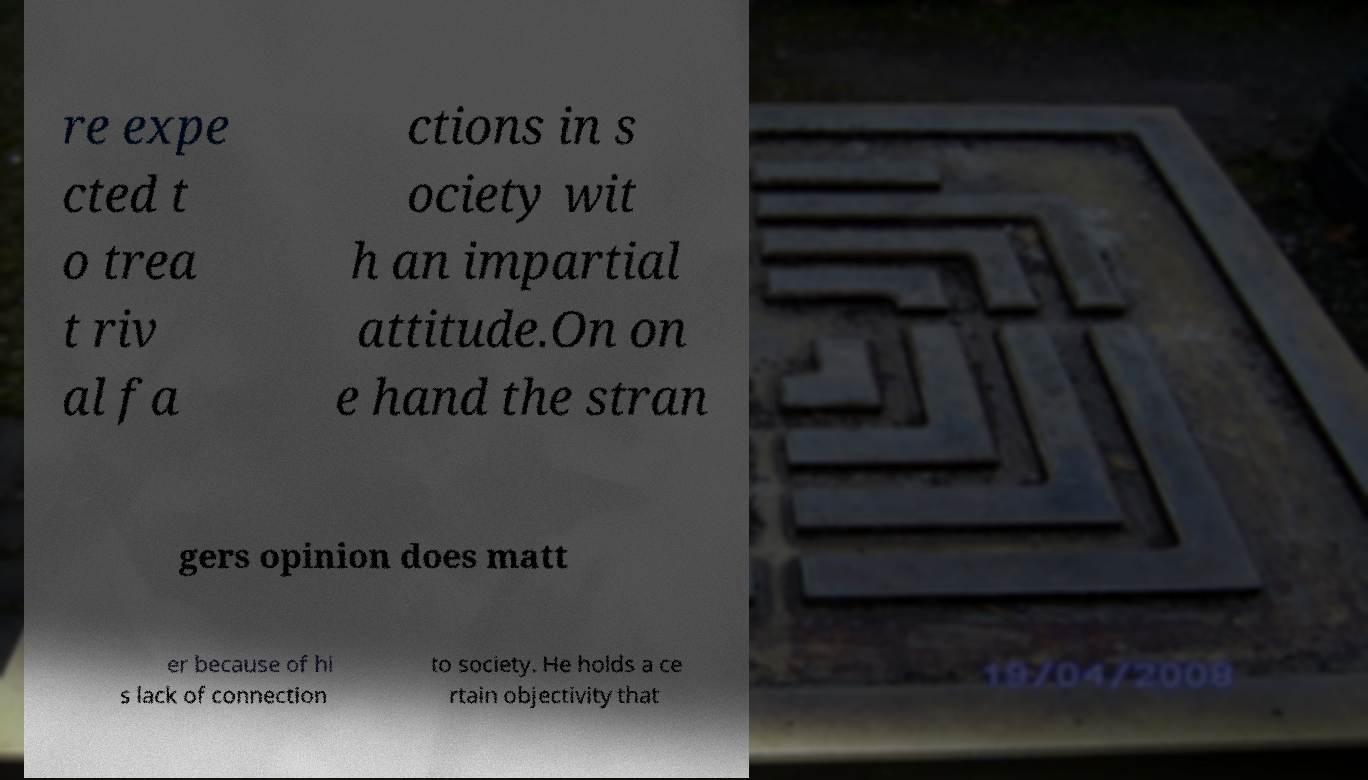There's text embedded in this image that I need extracted. Can you transcribe it verbatim? re expe cted t o trea t riv al fa ctions in s ociety wit h an impartial attitude.On on e hand the stran gers opinion does matt er because of hi s lack of connection to society. He holds a ce rtain objectivity that 